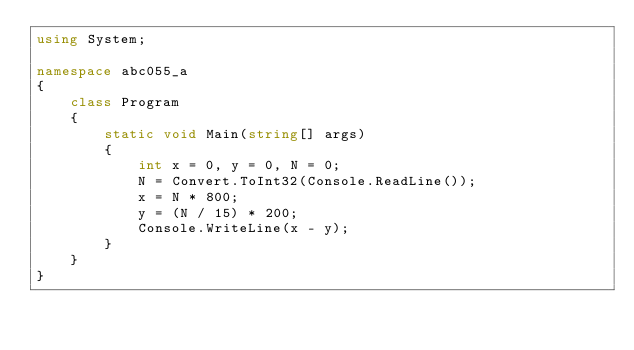<code> <loc_0><loc_0><loc_500><loc_500><_C#_>using System;

namespace abc055_a
{
    class Program
    {
        static void Main(string[] args)
        {
            int x = 0, y = 0, N = 0;
            N = Convert.ToInt32(Console.ReadLine());
            x = N * 800;
            y = (N / 15) * 200;
            Console.WriteLine(x - y);
        }
    }
}
</code> 